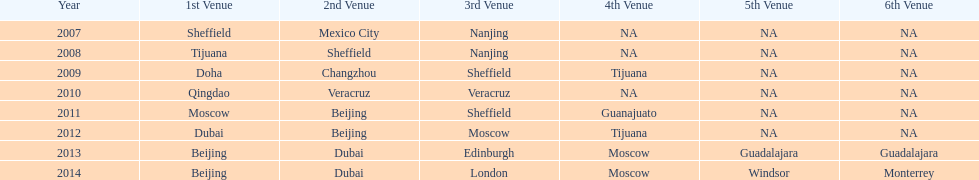What was the final year when tijuana served as a location? 2012. 